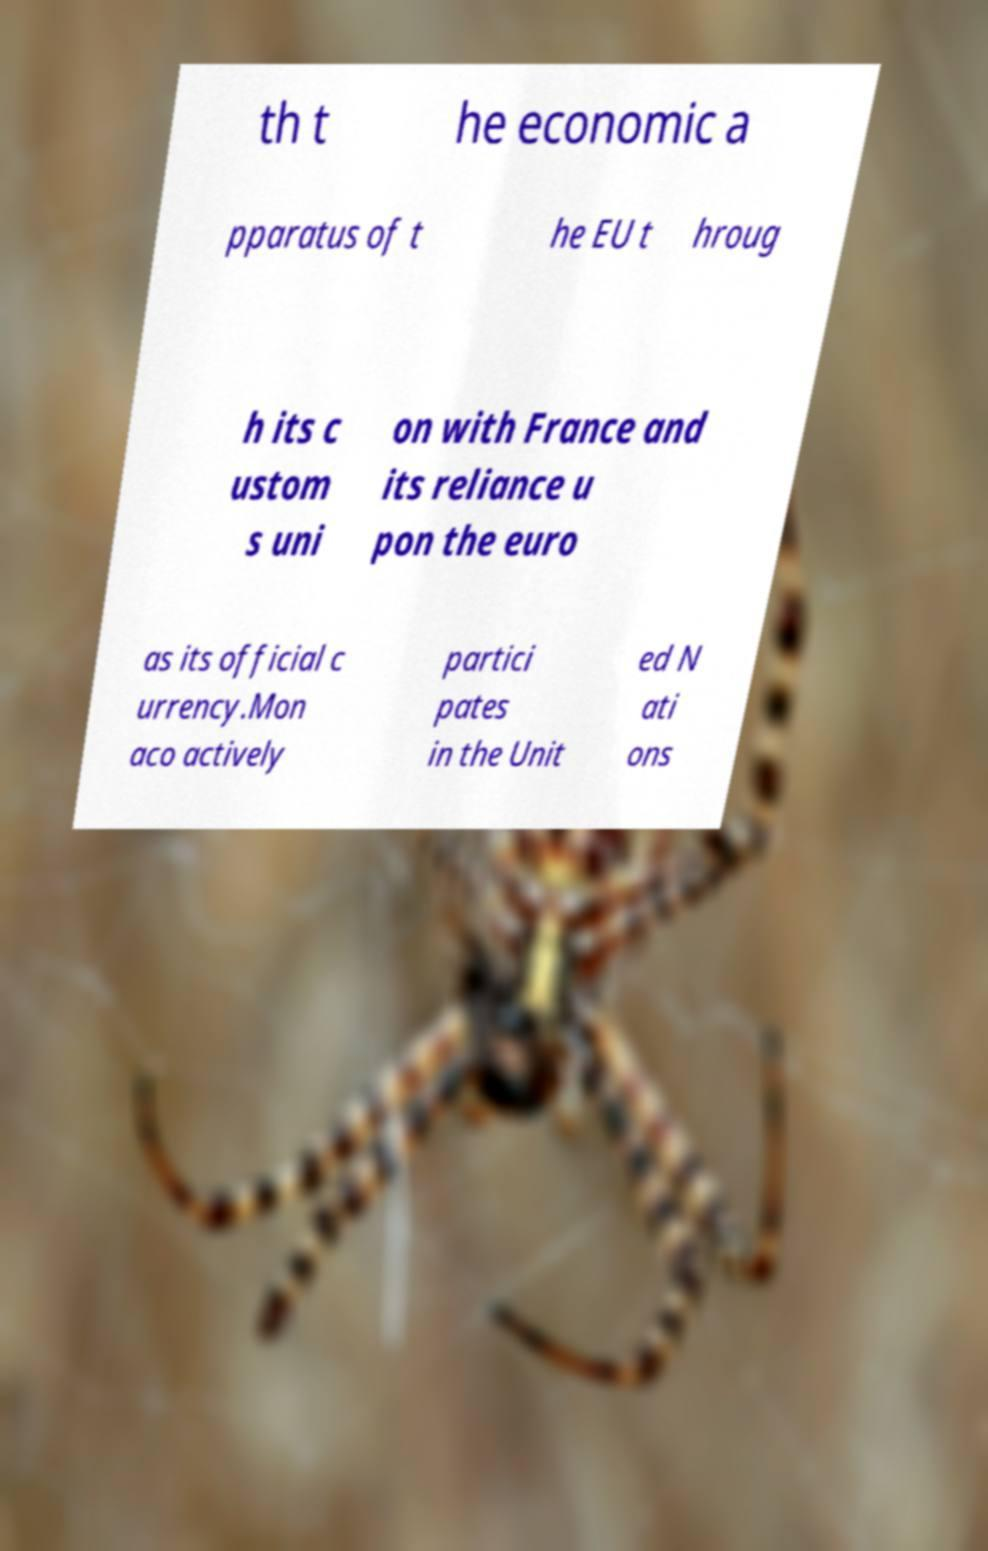Can you accurately transcribe the text from the provided image for me? th t he economic a pparatus of t he EU t hroug h its c ustom s uni on with France and its reliance u pon the euro as its official c urrency.Mon aco actively partici pates in the Unit ed N ati ons 